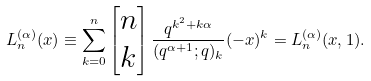<formula> <loc_0><loc_0><loc_500><loc_500>L _ { n } ^ { ( \alpha ) } ( x ) \equiv \sum _ { k = 0 } ^ { n } \begin{bmatrix} n \\ k \end{bmatrix} \frac { q ^ { k ^ { 2 } + k \alpha } } { ( q ^ { \alpha + 1 } ; q ) _ { k } } ( - x ) ^ { k } = L _ { n } ^ { ( \alpha ) } ( x , 1 ) .</formula> 